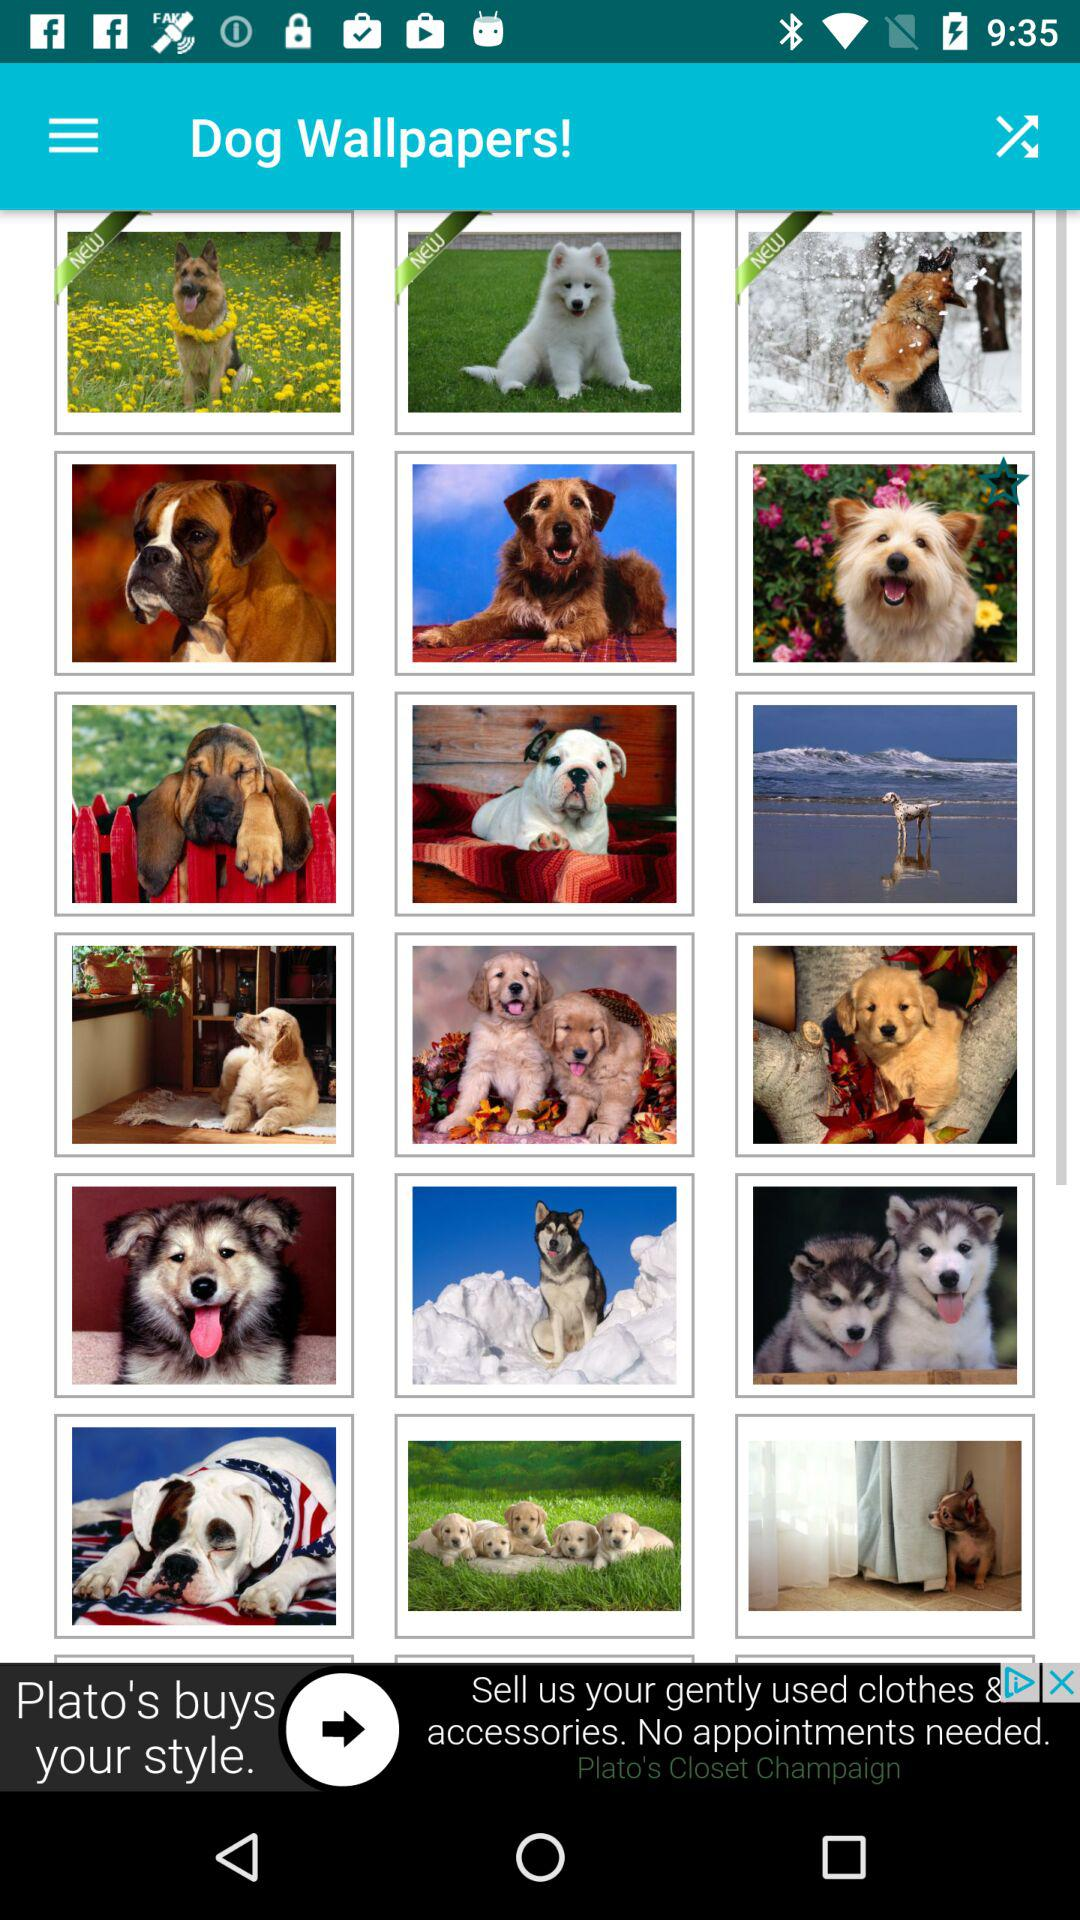What is the application name? The application name is "Dog Wallpapers!". 